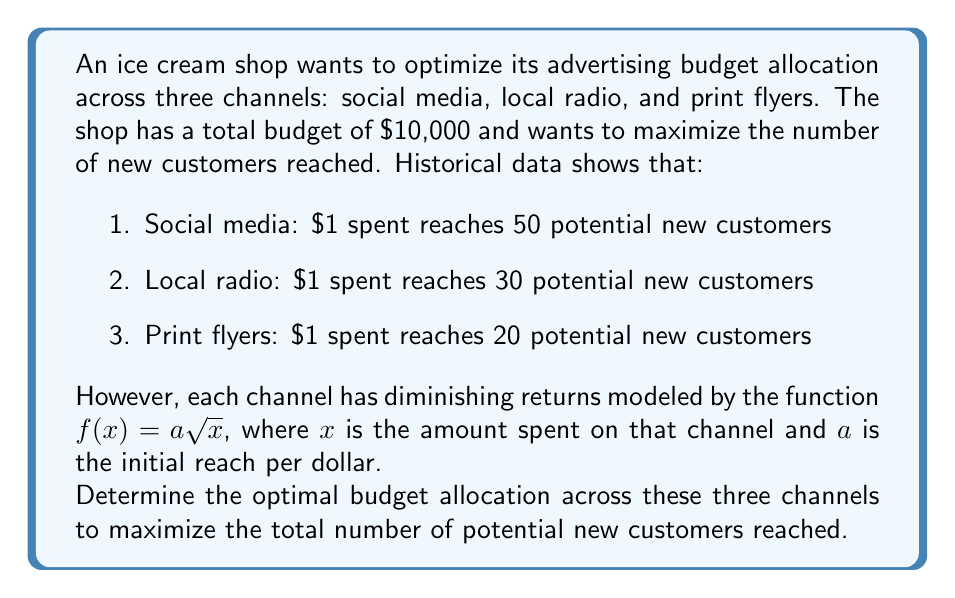Teach me how to tackle this problem. To solve this inverse problem, we'll use the method of Lagrange multipliers:

1. Define the objective function:
   $F(x, y, z) = 50\sqrt{x} + 30\sqrt{y} + 20\sqrt{z}$

2. Define the constraint:
   $g(x, y, z) = x + y + z - 10000 = 0$

3. Form the Lagrangian:
   $L(x, y, z, \lambda) = 50\sqrt{x} + 30\sqrt{y} + 20\sqrt{z} + \lambda(x + y + z - 10000)$

4. Take partial derivatives and set them equal to zero:
   $\frac{\partial L}{\partial x} = \frac{25}{\sqrt{x}} + \lambda = 0$
   $\frac{\partial L}{\partial y} = \frac{15}{\sqrt{y}} + \lambda = 0$
   $\frac{\partial L}{\partial z} = \frac{10}{\sqrt{z}} + \lambda = 0$
   $\frac{\partial L}{\partial \lambda} = x + y + z - 10000 = 0$

5. From the first three equations:
   $\frac{25}{\sqrt{x}} = \frac{15}{\sqrt{y}} = \frac{10}{\sqrt{z}} = -\lambda$

6. This implies:
   $\frac{x}{25^2} = \frac{y}{15^2} = \frac{z}{10^2}$

7. Let $k = \frac{x}{25^2} = \frac{y}{15^2} = \frac{z}{10^2}$

8. Substitute into the constraint equation:
   $25^2k + 15^2k + 10^2k = 10000$
   $k(625 + 225 + 100) = 10000$
   $k = \frac{10000}{950} = \frac{200}{19}$

9. Solve for x, y, and z:
   $x = 25^2 \cdot \frac{200}{19} = \frac{125000}{19} \approx 6578.95$
   $y = 15^2 \cdot \frac{200}{19} = \frac{45000}{19} \approx 2368.42$
   $z = 10^2 \cdot \frac{200}{19} = \frac{20000}{19} \approx 1052.63$

10. Round to the nearest dollar:
    $x = 6579$, $y = 2368$, $z = 1053$
Answer: Social media: $6579, Local radio: $2368, Print flyers: $1053 